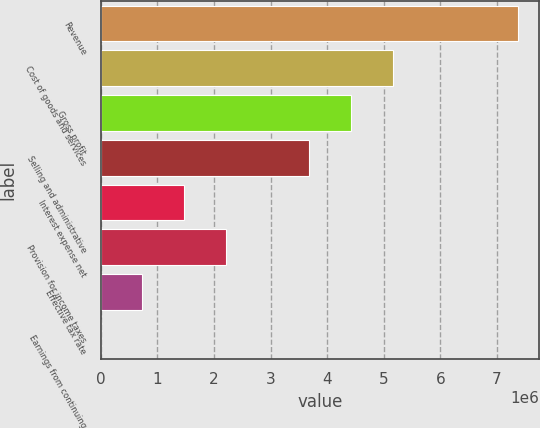Convert chart to OTSL. <chart><loc_0><loc_0><loc_500><loc_500><bar_chart><fcel>Revenue<fcel>Cost of goods and services<fcel>Gross profit<fcel>Selling and administrative<fcel>Interest expense net<fcel>Provision for income taxes<fcel>Effective tax rate<fcel>Earnings from continuing<nl><fcel>7.36915e+06<fcel>5.15841e+06<fcel>4.42149e+06<fcel>3.68458e+06<fcel>1.47383e+06<fcel>2.21075e+06<fcel>736919<fcel>4.09<nl></chart> 